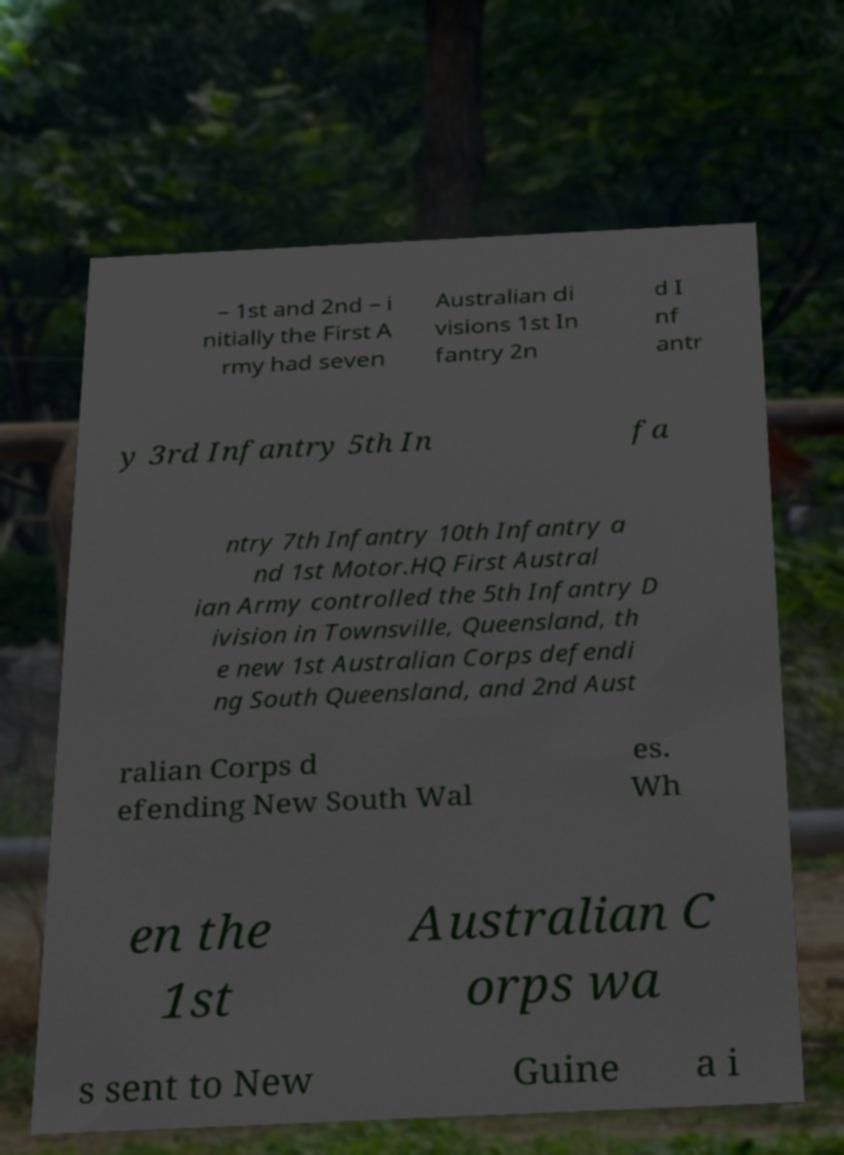I need the written content from this picture converted into text. Can you do that? – 1st and 2nd – i nitially the First A rmy had seven Australian di visions 1st In fantry 2n d I nf antr y 3rd Infantry 5th In fa ntry 7th Infantry 10th Infantry a nd 1st Motor.HQ First Austral ian Army controlled the 5th Infantry D ivision in Townsville, Queensland, th e new 1st Australian Corps defendi ng South Queensland, and 2nd Aust ralian Corps d efending New South Wal es. Wh en the 1st Australian C orps wa s sent to New Guine a i 